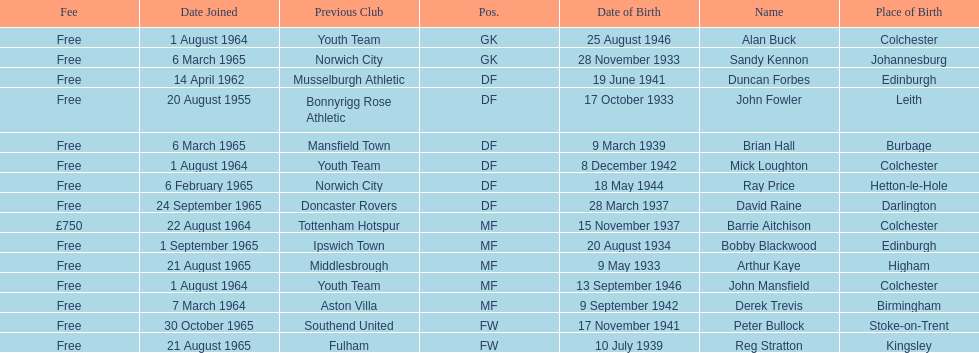What is the other expense noted, besides free? £750. 